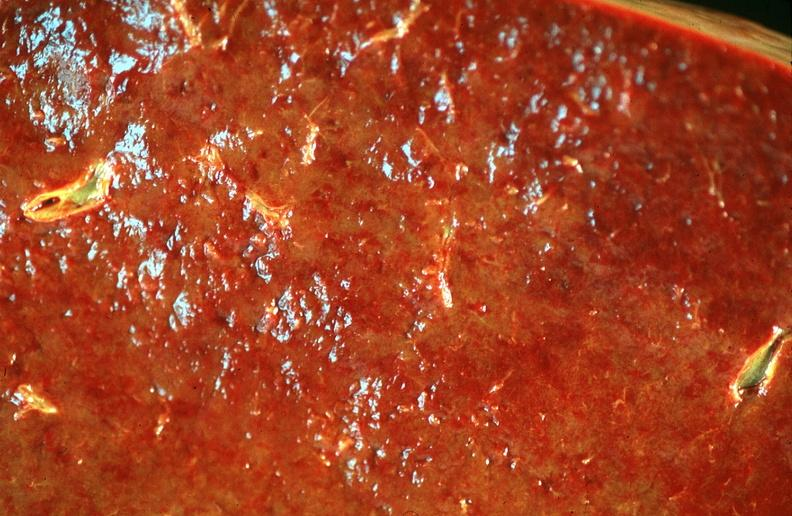what is present?
Answer the question using a single word or phrase. Hematologic 